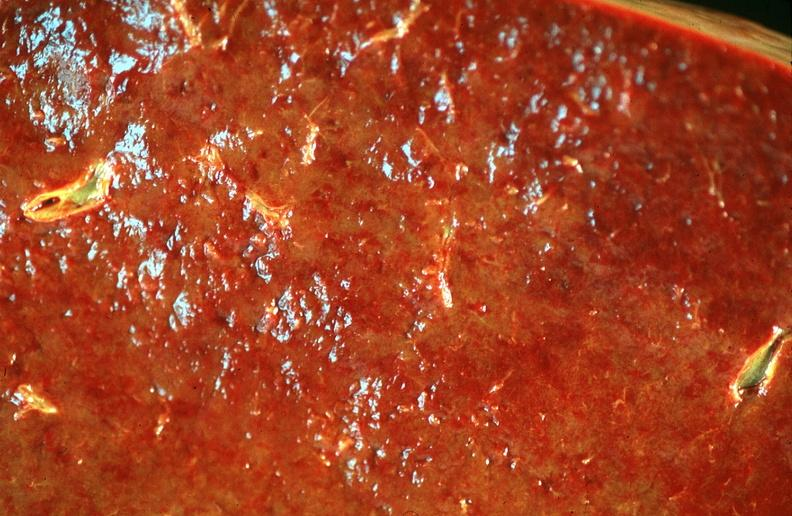what is present?
Answer the question using a single word or phrase. Hematologic 